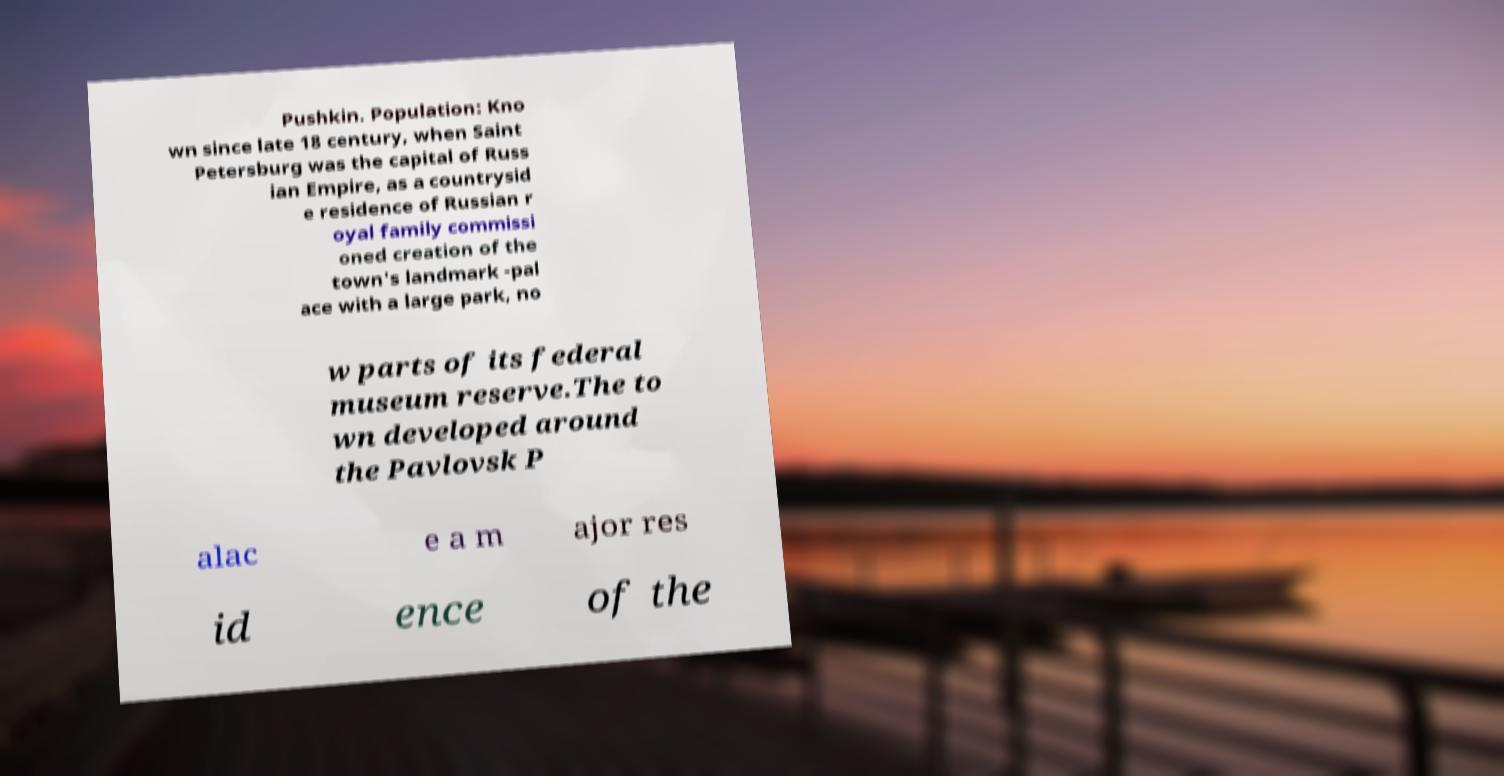Can you read and provide the text displayed in the image?This photo seems to have some interesting text. Can you extract and type it out for me? Pushkin. Population: Kno wn since late 18 century, when Saint Petersburg was the capital of Russ ian Empire, as a countrysid e residence of Russian r oyal family commissi oned creation of the town's landmark -pal ace with a large park, no w parts of its federal museum reserve.The to wn developed around the Pavlovsk P alac e a m ajor res id ence of the 